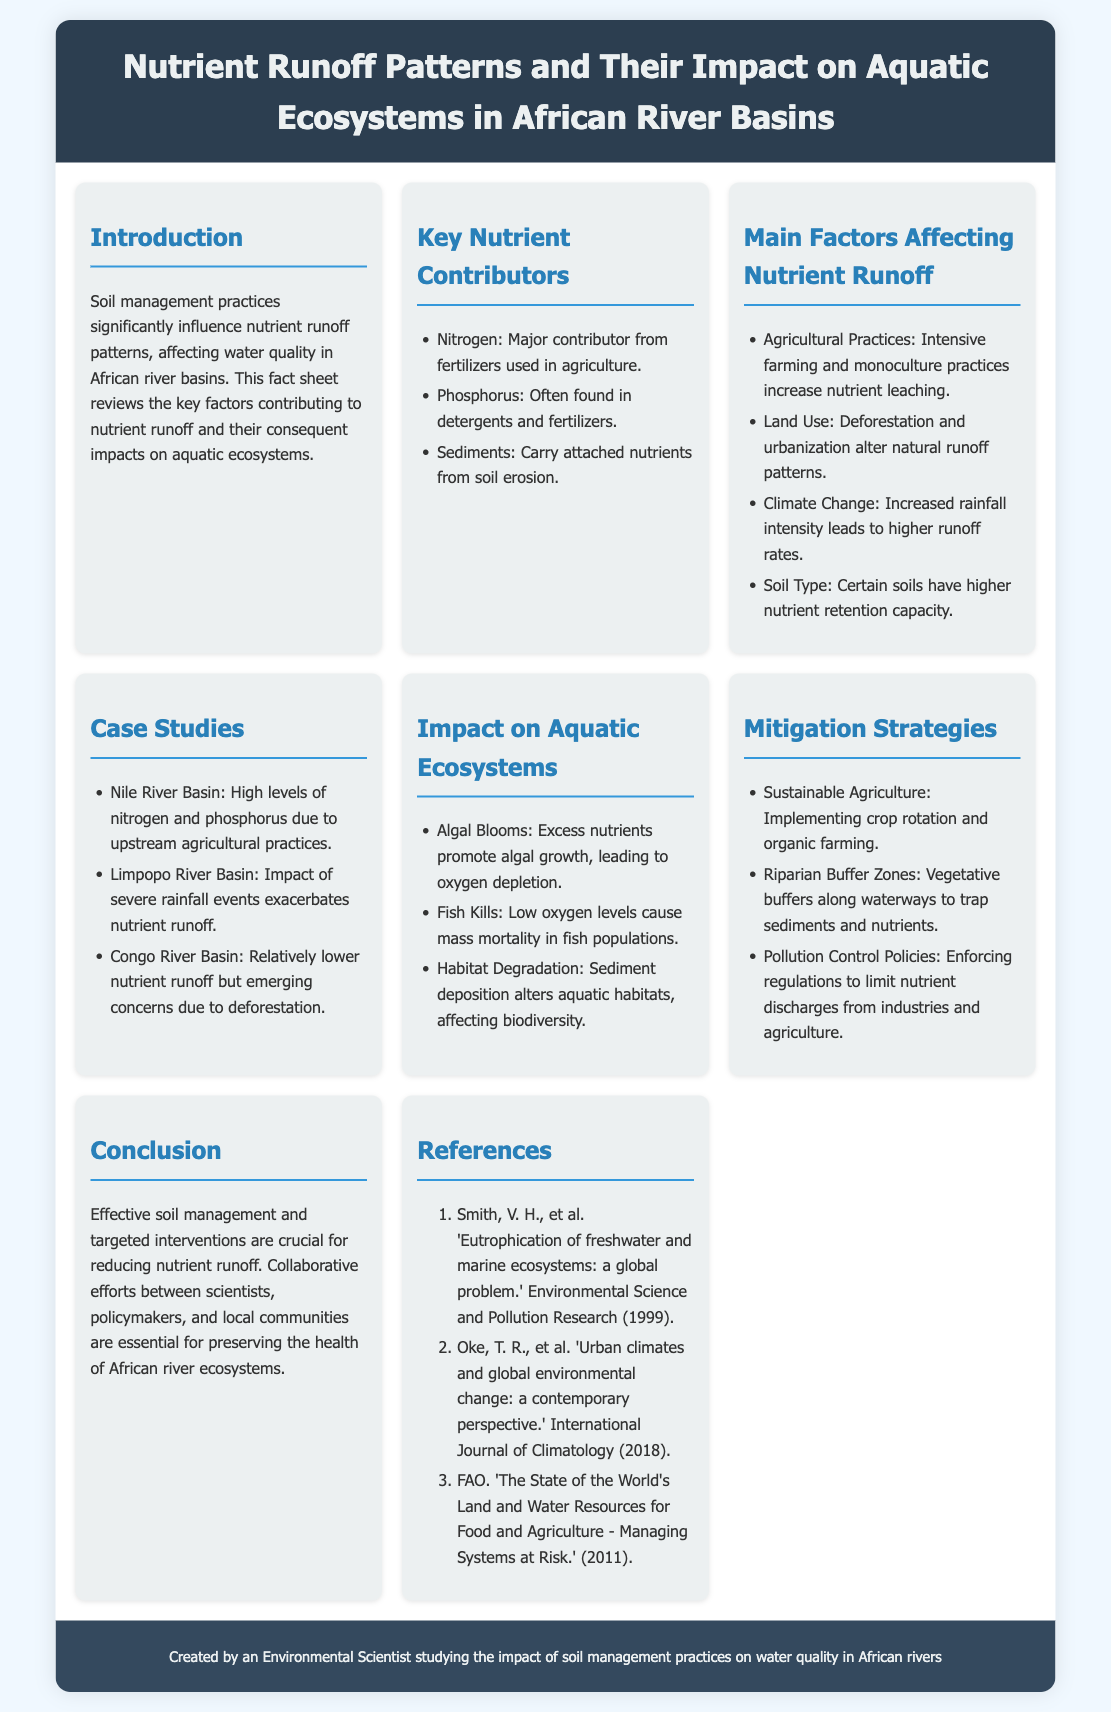What is the main focus of the fact sheet? The main focus of the fact sheet is the influence of soil management practices on nutrient runoff patterns and their impact on water quality in African river basins.
Answer: Soil management practices What are the three key nutrient contributors mentioned? The document specifies nitrogen, phosphorus, and sediments as key nutrient contributors affecting aquatic ecosystems.
Answer: Nitrogen, phosphorus, sediments Which river basin is highlighted for high levels of nitrogen and phosphorus? The Nile River Basin is mentioned as having high levels of nitrogen and phosphorus due to agricultural practices.
Answer: Nile River Basin What is one impact of excess nutrients on aquatic ecosystems? Algal blooms are noted as a significant impact caused by excess nutrients in aquatic ecosystems.
Answer: Algal Blooms What type of agriculture is suggested as a mitigation strategy? The document suggests implementing sustainable agriculture as a strategy to mitigate nutrient runoff.
Answer: Sustainable Agriculture How does climate change affect nutrient runoff according to the document? It is stated that climate change increases rainfall intensity, which leads to higher nutrient runoff rates.
Answer: Higher nutrient runoff rates What is one of the recommended pollution control strategies? The document mentions enforcing regulations to limit nutrient discharges as a key pollution control strategy.
Answer: Pollution Control Policies How many references are listed in the document? The fact sheet contains three references that support the information presented within it.
Answer: Three references 